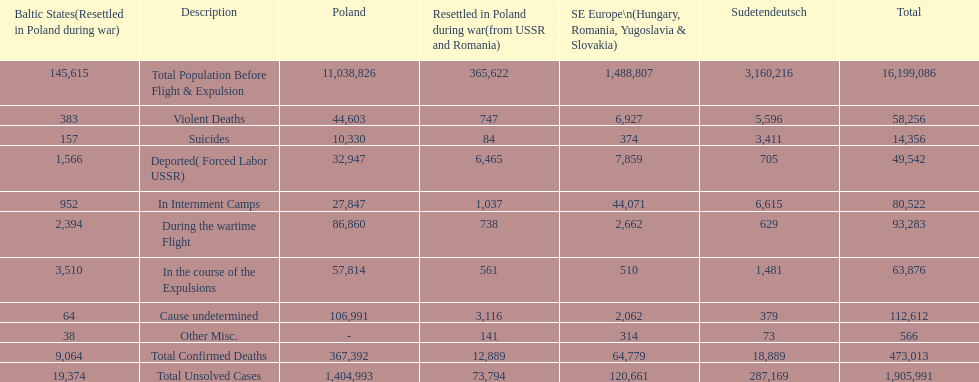What was the cause of the most deaths? Cause undetermined. 